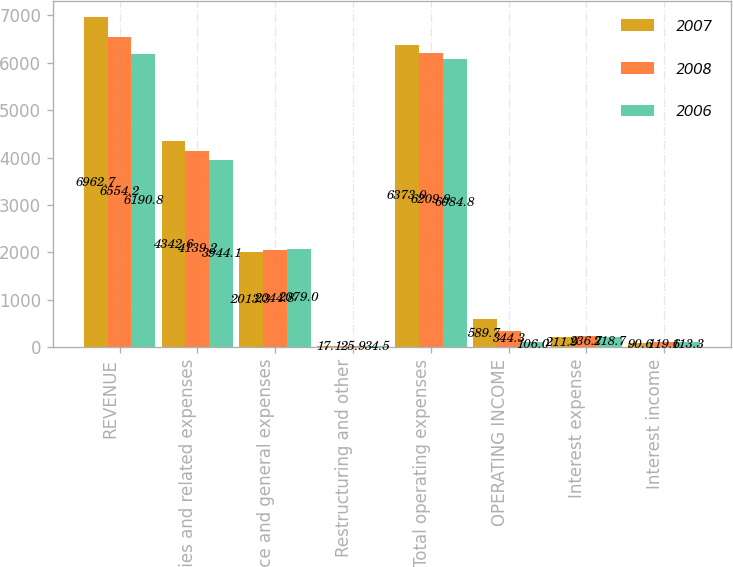Convert chart to OTSL. <chart><loc_0><loc_0><loc_500><loc_500><stacked_bar_chart><ecel><fcel>REVENUE<fcel>Salaries and related expenses<fcel>Office and general expenses<fcel>Restructuring and other<fcel>Total operating expenses<fcel>OPERATING INCOME<fcel>Interest expense<fcel>Interest income<nl><fcel>2007<fcel>6962.7<fcel>4342.6<fcel>2013.3<fcel>17.1<fcel>6373<fcel>589.7<fcel>211.9<fcel>90.6<nl><fcel>2008<fcel>6554.2<fcel>4139.2<fcel>2044.8<fcel>25.9<fcel>6209.9<fcel>344.3<fcel>236.7<fcel>119.6<nl><fcel>2006<fcel>6190.8<fcel>3944.1<fcel>2079<fcel>34.5<fcel>6084.8<fcel>106<fcel>218.7<fcel>113.3<nl></chart> 